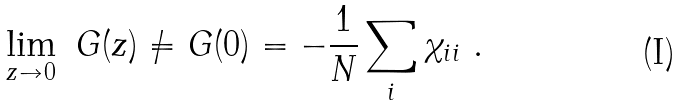Convert formula to latex. <formula><loc_0><loc_0><loc_500><loc_500>\lim _ { z \to 0 } \ G ( z ) \neq G ( 0 ) = - \frac { 1 } { N } \sum _ { i } \chi _ { i i } \ .</formula> 